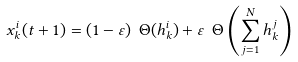<formula> <loc_0><loc_0><loc_500><loc_500>x _ { k } ^ { i } ( t + 1 ) = ( 1 - \varepsilon ) \ \Theta ( h _ { k } ^ { i } ) + \varepsilon \ \Theta \left ( \sum _ { j = 1 } ^ { N } h _ { k } ^ { j } \right )</formula> 